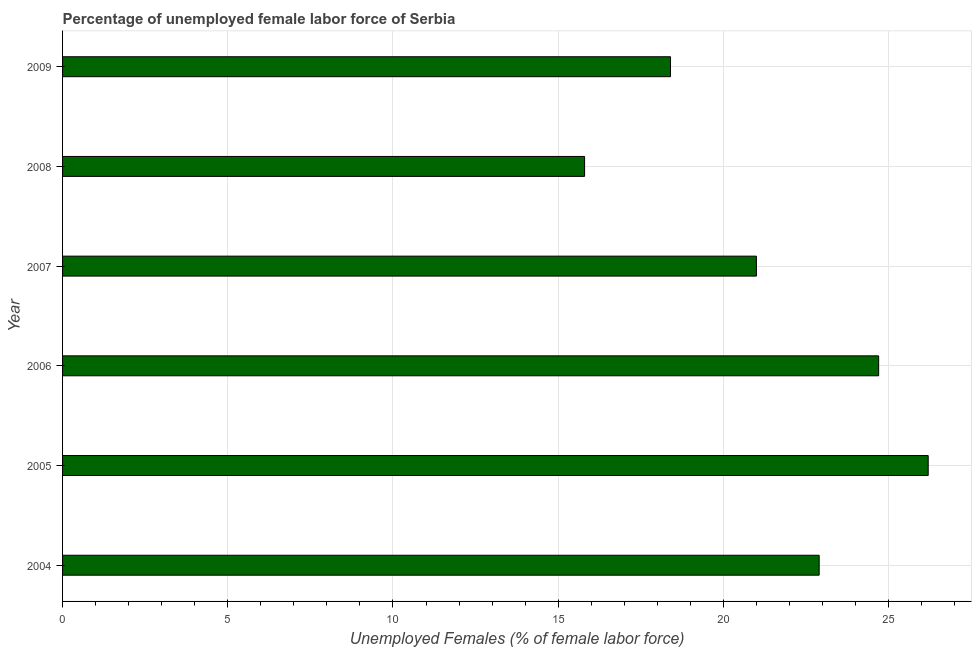Does the graph contain grids?
Give a very brief answer. Yes. What is the title of the graph?
Keep it short and to the point. Percentage of unemployed female labor force of Serbia. What is the label or title of the X-axis?
Your answer should be compact. Unemployed Females (% of female labor force). What is the label or title of the Y-axis?
Provide a short and direct response. Year. What is the total unemployed female labour force in 2009?
Ensure brevity in your answer.  18.4. Across all years, what is the maximum total unemployed female labour force?
Ensure brevity in your answer.  26.2. Across all years, what is the minimum total unemployed female labour force?
Offer a terse response. 15.8. In which year was the total unemployed female labour force maximum?
Your answer should be very brief. 2005. What is the sum of the total unemployed female labour force?
Provide a short and direct response. 129. What is the difference between the total unemployed female labour force in 2004 and 2009?
Provide a short and direct response. 4.5. What is the average total unemployed female labour force per year?
Offer a terse response. 21.5. What is the median total unemployed female labour force?
Your answer should be very brief. 21.95. In how many years, is the total unemployed female labour force greater than 2 %?
Your answer should be very brief. 6. Do a majority of the years between 2008 and 2005 (inclusive) have total unemployed female labour force greater than 3 %?
Offer a terse response. Yes. What is the ratio of the total unemployed female labour force in 2006 to that in 2009?
Keep it short and to the point. 1.34. Is the sum of the total unemployed female labour force in 2004 and 2009 greater than the maximum total unemployed female labour force across all years?
Provide a short and direct response. Yes. Are all the bars in the graph horizontal?
Your answer should be very brief. Yes. What is the difference between two consecutive major ticks on the X-axis?
Provide a short and direct response. 5. What is the Unemployed Females (% of female labor force) of 2004?
Your answer should be compact. 22.9. What is the Unemployed Females (% of female labor force) in 2005?
Provide a short and direct response. 26.2. What is the Unemployed Females (% of female labor force) in 2006?
Give a very brief answer. 24.7. What is the Unemployed Females (% of female labor force) of 2008?
Your answer should be very brief. 15.8. What is the Unemployed Females (% of female labor force) of 2009?
Give a very brief answer. 18.4. What is the difference between the Unemployed Females (% of female labor force) in 2004 and 2009?
Your answer should be compact. 4.5. What is the difference between the Unemployed Females (% of female labor force) in 2005 and 2006?
Your response must be concise. 1.5. What is the difference between the Unemployed Females (% of female labor force) in 2005 and 2007?
Your response must be concise. 5.2. What is the difference between the Unemployed Females (% of female labor force) in 2005 and 2009?
Make the answer very short. 7.8. What is the difference between the Unemployed Females (% of female labor force) in 2006 and 2007?
Your response must be concise. 3.7. What is the difference between the Unemployed Females (% of female labor force) in 2006 and 2009?
Ensure brevity in your answer.  6.3. What is the difference between the Unemployed Females (% of female labor force) in 2007 and 2008?
Your answer should be very brief. 5.2. What is the difference between the Unemployed Females (% of female labor force) in 2008 and 2009?
Give a very brief answer. -2.6. What is the ratio of the Unemployed Females (% of female labor force) in 2004 to that in 2005?
Ensure brevity in your answer.  0.87. What is the ratio of the Unemployed Females (% of female labor force) in 2004 to that in 2006?
Provide a succinct answer. 0.93. What is the ratio of the Unemployed Females (% of female labor force) in 2004 to that in 2007?
Keep it short and to the point. 1.09. What is the ratio of the Unemployed Females (% of female labor force) in 2004 to that in 2008?
Provide a short and direct response. 1.45. What is the ratio of the Unemployed Females (% of female labor force) in 2004 to that in 2009?
Your answer should be very brief. 1.25. What is the ratio of the Unemployed Females (% of female labor force) in 2005 to that in 2006?
Your answer should be compact. 1.06. What is the ratio of the Unemployed Females (% of female labor force) in 2005 to that in 2007?
Keep it short and to the point. 1.25. What is the ratio of the Unemployed Females (% of female labor force) in 2005 to that in 2008?
Your answer should be compact. 1.66. What is the ratio of the Unemployed Females (% of female labor force) in 2005 to that in 2009?
Offer a very short reply. 1.42. What is the ratio of the Unemployed Females (% of female labor force) in 2006 to that in 2007?
Ensure brevity in your answer.  1.18. What is the ratio of the Unemployed Females (% of female labor force) in 2006 to that in 2008?
Your response must be concise. 1.56. What is the ratio of the Unemployed Females (% of female labor force) in 2006 to that in 2009?
Ensure brevity in your answer.  1.34. What is the ratio of the Unemployed Females (% of female labor force) in 2007 to that in 2008?
Provide a short and direct response. 1.33. What is the ratio of the Unemployed Females (% of female labor force) in 2007 to that in 2009?
Provide a succinct answer. 1.14. What is the ratio of the Unemployed Females (% of female labor force) in 2008 to that in 2009?
Ensure brevity in your answer.  0.86. 